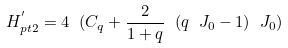Convert formula to latex. <formula><loc_0><loc_0><loc_500><loc_500>H _ { p t 2 } ^ { ^ { \prime } } = 4 \ ( C _ { q } + \frac { 2 } { 1 + q } \ ( q \ J _ { 0 } - 1 ) \ J _ { 0 } )</formula> 